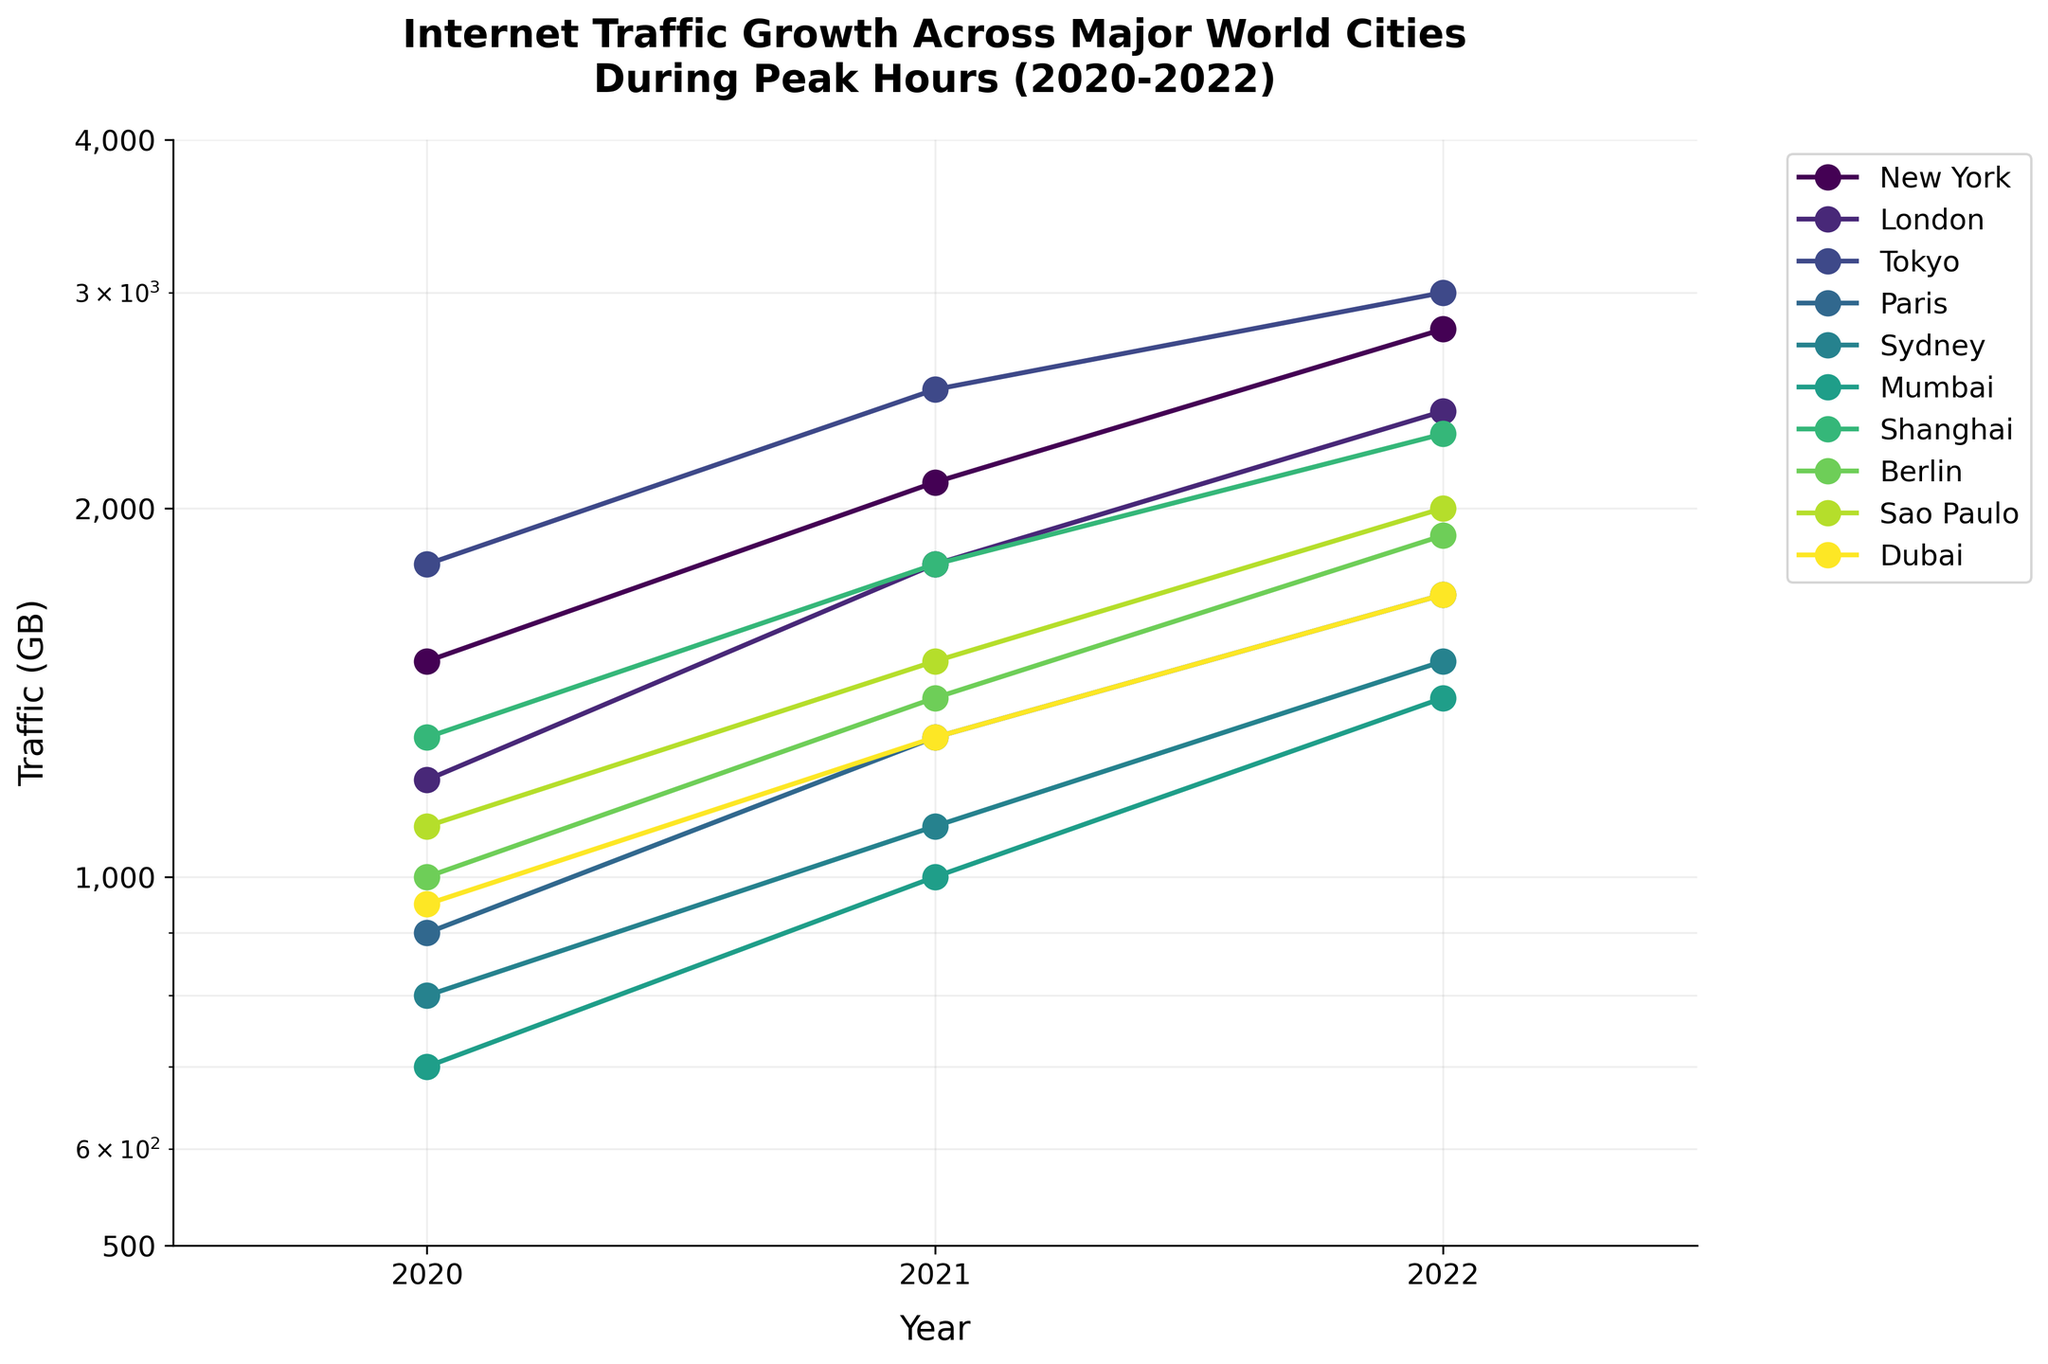What's the title of the plot? The title of the plot is displayed at the top of the figure in bold and larger font size. The title usually gives a concise summary of the data being presented.
Answer: Internet Traffic Growth Across Major World Cities During Peak Hours (2020-2022) What is the y-axis scale of the plot? The y-axis scale is mentioned explicitly in the question and can be confirmed by observing that the distance between tick marks increases multiplicatively. This indicates a logarithmic scale.
Answer: Logarithmic Which city had the highest internet traffic in 2022? To identify the city with the highest traffic in 2022, one must refer to the y-axis positions of the data points for 2022. The city with the data point highest up on this axis in 2022 is selected. In this plot, Tokyo’s 2022 data point is the highest.
Answer: Tokyo What trend can be observed in New York's internet traffic from 2020 to 2022? Examining the data points along the line graph for New York over the years 2020, 2021, and 2022, one can see that the traffic value increases each year.
Answer: Increasing trend What is the range of internet traffic values shown on the y-axis? The range of values can be observed from the lowest to the highest tick on the y-axis. The tick marks scale from 500 to 4000 GB.
Answer: 500 to 4000 GB How much did Paris' internet traffic grow from 2020 to 2022? To determine the growth, subtract the 2020 value for Paris from its 2022 value. Thus, 1700 GB (2022) - 900 GB (2020) = 800 GB.
Answer: 800 GB Which city showed the least growth in internet traffic from 2021 to 2022? To find this, calculate the difference between 2021 and 2022 traffic for each city and identify the city with the smallest difference. Sydney's growth is the least, showing an increase from 1100 GB to 1500 GB, a difference of 400 GB.
Answer: Sydney Compare the internet traffic trends of Sydney and Mumbai from 2020 to 2022. Both cities show growth in their internet traffic. However, the exact values show different patterns. Sydney goes from 800 GB to 1100 GB to 1500 GB, and Mumbai rises from 700 GB to 1000 GB to 1400 GB. The overall pattern indicates an increase in traffic for both cities, but Sydney grows slightly more steadily than Mumbai.
Answer: Both cities show increasing trends, but Sydney has a steadier increase How does the traffic in New York in 2020 compare to the traffic in Shenzehen in 2022? First, locate New York's traffic value for 2020 and Shenzehen's for 2022. Then, compare these values. New York in 2020 shows 1500 GB, whereas Shenzehen in 2022 displays the highest point at 2300 GB, indicating the latter is greater.
Answer: Shenzehen's 2022 traffic is higher Which year saw the greatest increase in internet traffic for Tokyo? To find which year had the greatest increase, compare the differences between 2021's and 2020's traffic, and 2022's and 2021's traffic for Tokyo. The increase from 2500 GB in 2021 to 3000 GB in 2022 is smaller than the increase from 1800 GB in 2020 to 2500 GB in 2021.
Answer: 2021 